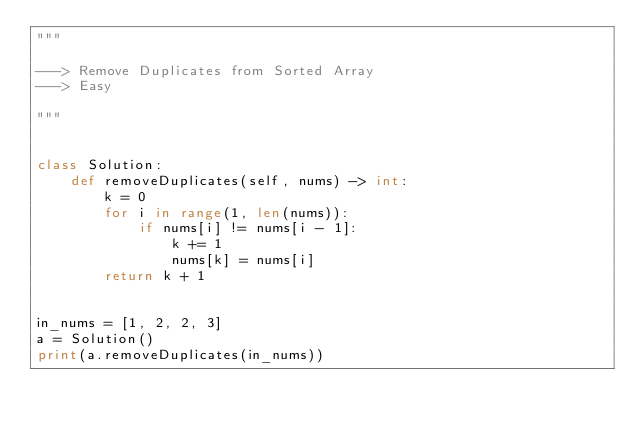Convert code to text. <code><loc_0><loc_0><loc_500><loc_500><_Python_>"""

---> Remove Duplicates from Sorted Array
---> Easy

"""


class Solution:
    def removeDuplicates(self, nums) -> int:
        k = 0
        for i in range(1, len(nums)):
            if nums[i] != nums[i - 1]:
                k += 1
                nums[k] = nums[i]
        return k + 1


in_nums = [1, 2, 2, 3]
a = Solution()
print(a.removeDuplicates(in_nums))
</code> 